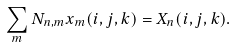<formula> <loc_0><loc_0><loc_500><loc_500>\sum _ { m } N _ { n , m } x _ { m } ( i , j , k ) = X _ { n } ( i , j , k ) .</formula> 